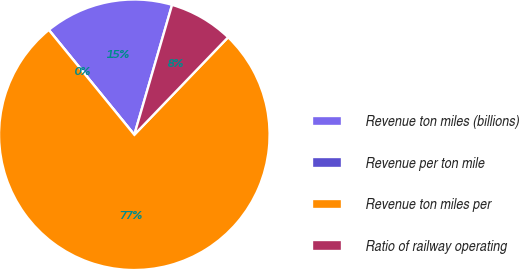<chart> <loc_0><loc_0><loc_500><loc_500><pie_chart><fcel>Revenue ton miles (billions)<fcel>Revenue per ton mile<fcel>Revenue ton miles per<fcel>Ratio of railway operating<nl><fcel>15.39%<fcel>0.0%<fcel>76.92%<fcel>7.69%<nl></chart> 